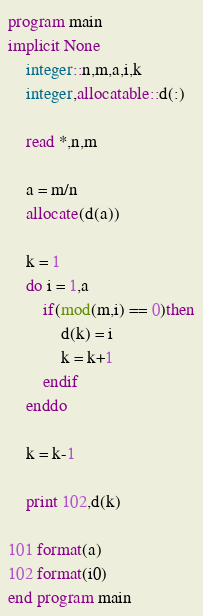Convert code to text. <code><loc_0><loc_0><loc_500><loc_500><_FORTRAN_>program main
implicit None
	integer::n,m,a,i,k
	integer,allocatable::d(:)
	
	read *,n,m
	
	a = m/n
	allocate(d(a))
	
	k = 1
	do i = 1,a
		if(mod(m,i) == 0)then
			d(k) = i
			k = k+1
		endif
	enddo
	
	k = k-1
	
	print 102,d(k)

101 format(a)
102 format(i0)
end program main</code> 